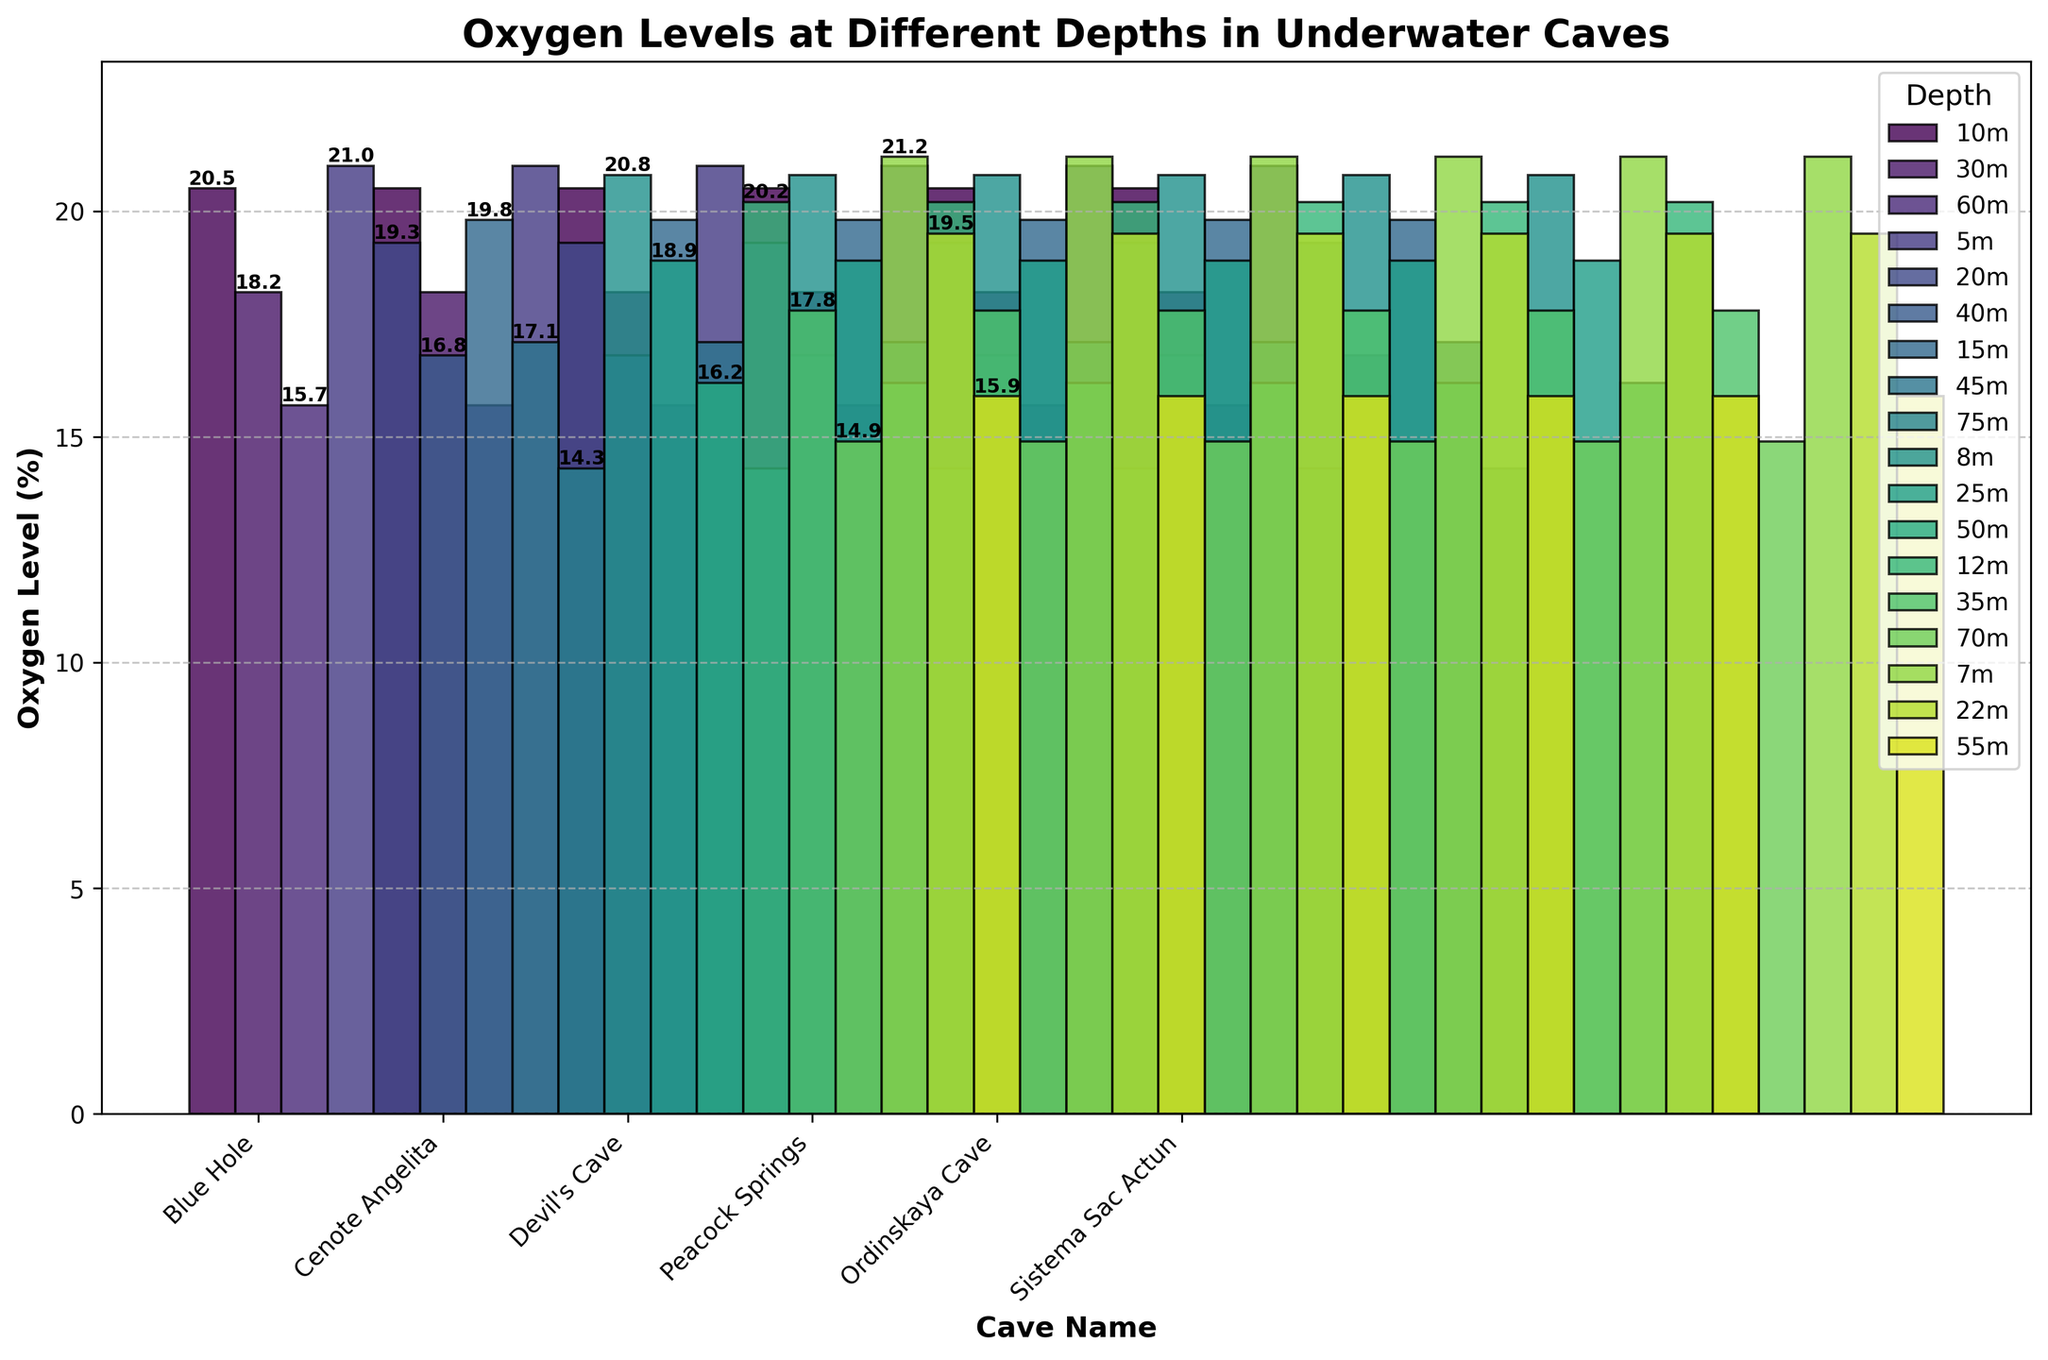What is the oxygen level at 10 meters in the Blue Hole? We need to look at the bar representing the Blue Hole at the 10-meter depth from the x-axis. The oxygen level is labeled above the bar.
Answer: 20.5% Which cave has the lowest oxygen level at 45 meters? Identify the bar representing each cave at the 45-meter depth and compare the heights. The Devil's Cave has the shortest bar.
Answer: Devil's Cave What is the average oxygen level at 20 meters deep across all caves? Sum the oxygen levels at 20 meters for all caves and divide by the number of caves. (19.3 + 19.5) / 2 = 19.4
Answer: 19.4 Is the oxygen level higher at 5 meters in Cenote Angelita or at 8 meters in Peacock Springs? Compare the heights or the labels of the bars representing these depths for Cenote Angelita and Peacock Springs. Cenote Angelita has an oxygen level of 21.0%, and Peacock Springs has 20.8%.
Answer: Cenote Angelita Which cave has the steepest decrease in oxygen level from its shallowest to its deepest depth? Calculate the difference in oxygen levels between the shallowest and deepest depths for each cave and identify the largest decrease. Blue Hole: 20.5 - 15.7 = 4.8 Cenote Angelita: 21.0 - 16.8 = 4.2 Devil's Cave: 19.8 - 14.3 = 5.5 Peacock Springs: 20.8 - 16.2 = 4.6 Ordinskaya Cave: 20.2 - 14.9 = 5.3 Sistema Sac Actun: 21.2 - 15.9 = 5.3 The Devil's Cave shows the steepest decrease.
Answer: Devil's Cave Which cave maintains an oxygen level above 18% at 35 meters deep? Look at the bar representing each cave at the 35-meter depth and check if the value is above 18%. Ordinskaya Cave has an oxygen level of 17.8%, which is below 18%. The other caves do not have data points for 35 meters.
Answer: None 